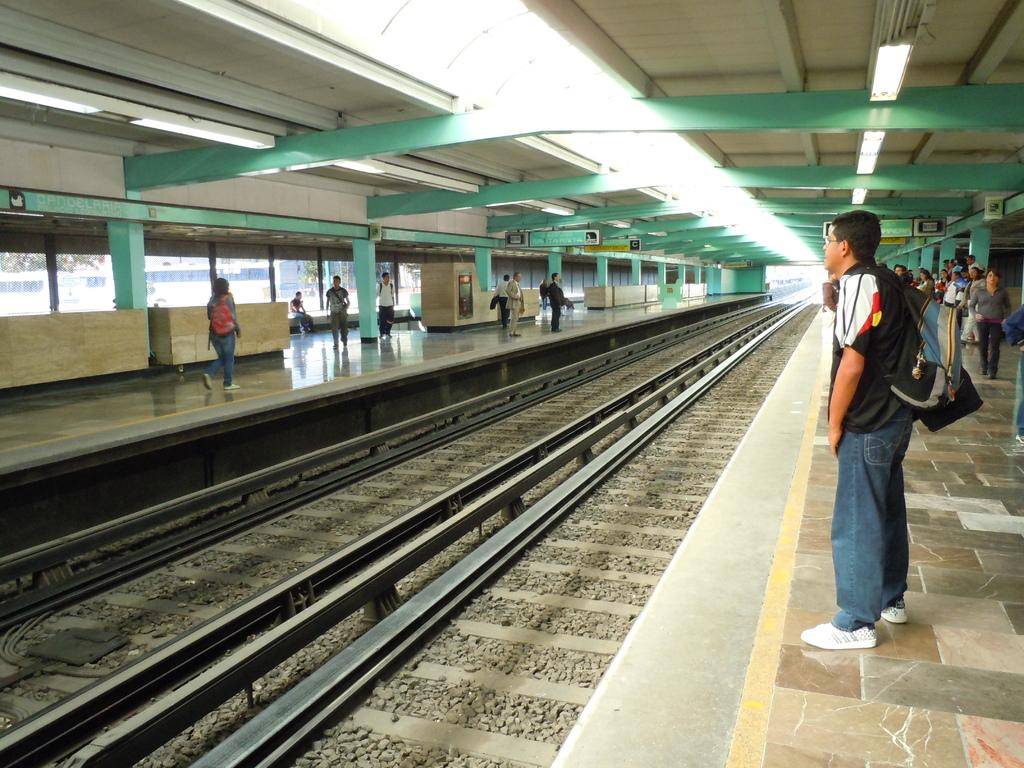What type of location is depicted in the image? There is a railway station in the image. What can be seen on the platform at the railway station? There are people standing on the platform. What is located at the center of the image? There are tracks at the center of the image. What is visible at the top of the image? There are boards and lights visible at the top of the image. What type of poison is being served to the children in the image? There are no children or poison present in the image; it depicts a railway station with people on the platform and tracks in the center. 